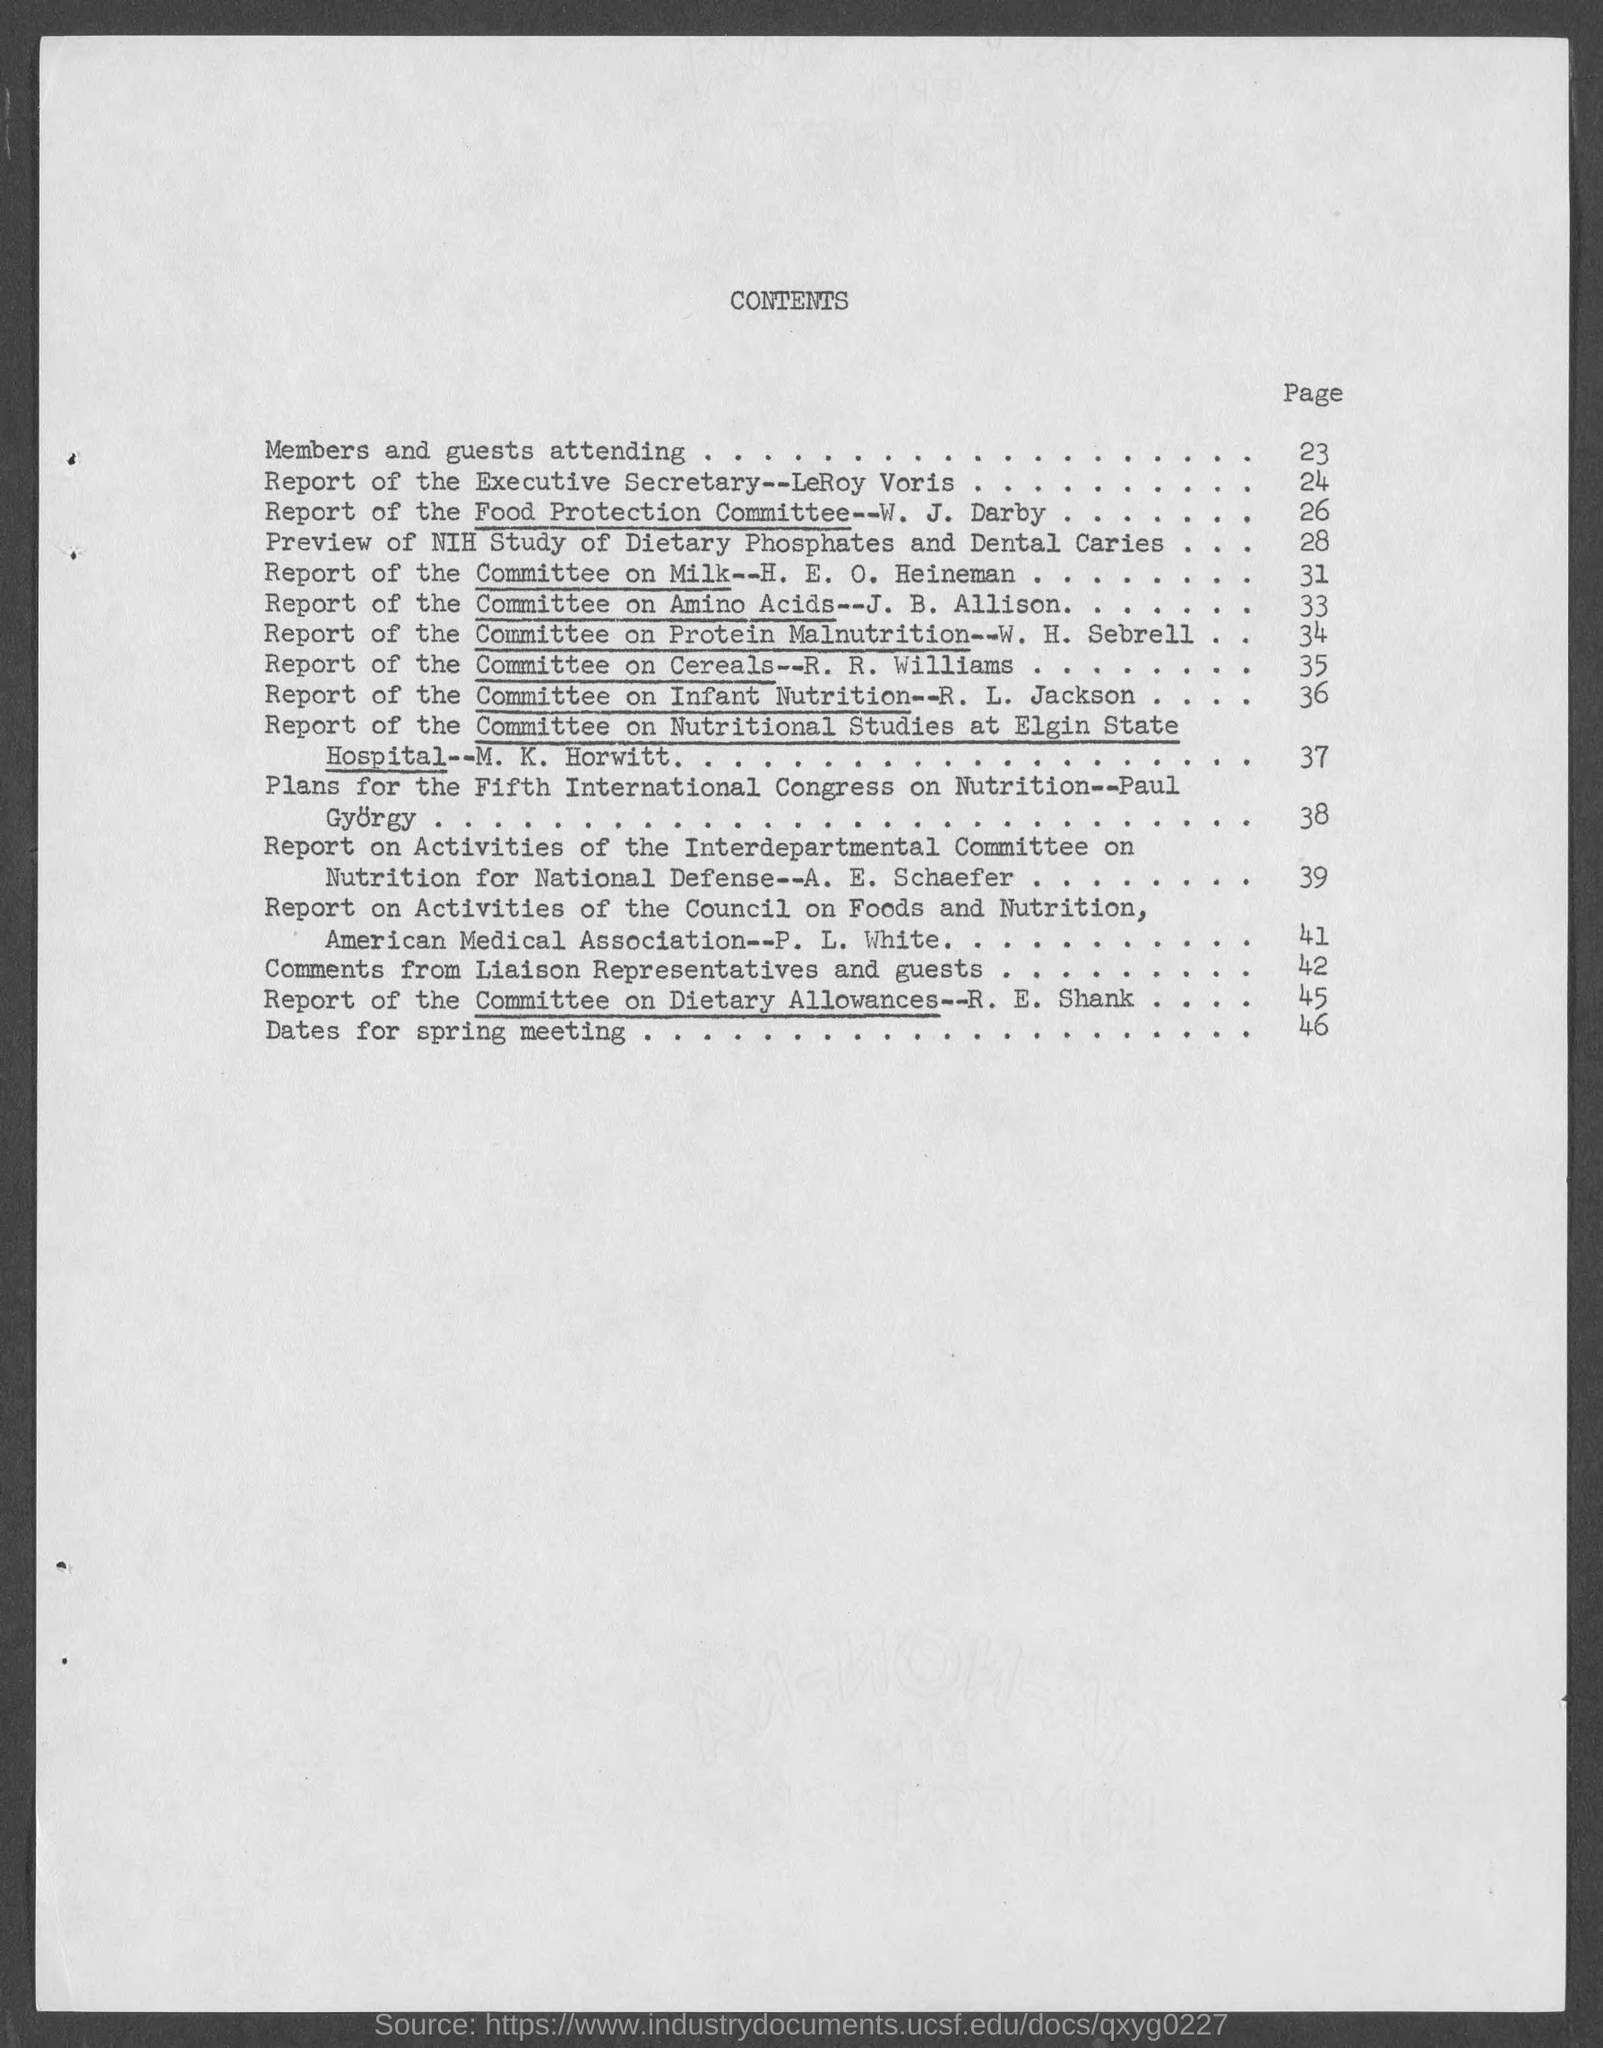Indicate a few pertinent items in this graphic. The page number for members and guests attending is 23. The page number for the dates of the spring meeting is 46. The heading of the page is 'Contents', which provides a comprehensive overview of the various sections included within. 